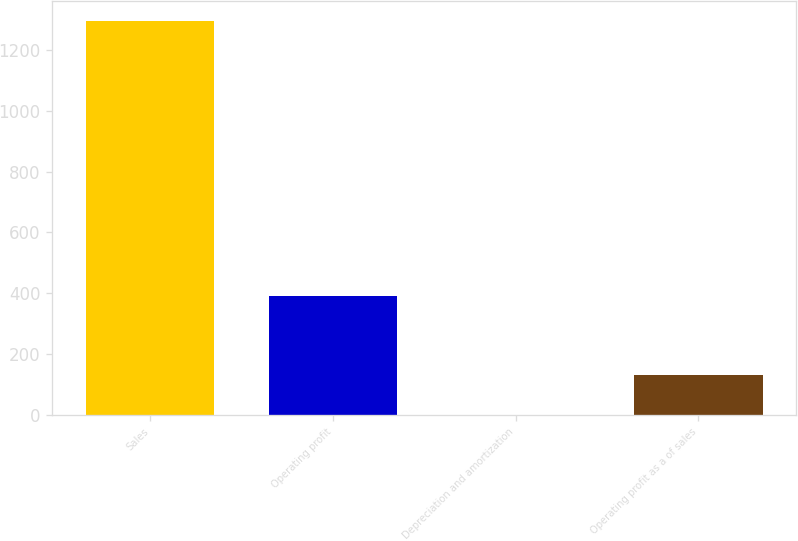Convert chart to OTSL. <chart><loc_0><loc_0><loc_500><loc_500><bar_chart><fcel>Sales<fcel>Operating profit<fcel>Depreciation and amortization<fcel>Operating profit as a of sales<nl><fcel>1294.2<fcel>389.38<fcel>1.6<fcel>130.86<nl></chart> 